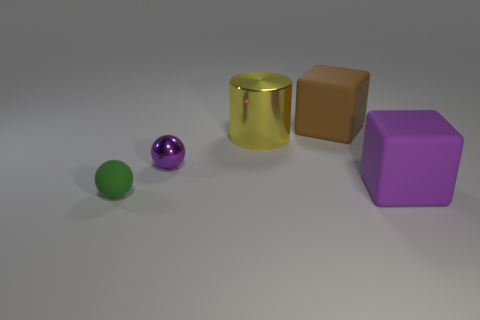Add 3 cyan rubber cylinders. How many objects exist? 8 Subtract all blocks. How many objects are left? 3 Add 5 metallic balls. How many metallic balls exist? 6 Subtract 0 brown cylinders. How many objects are left? 5 Subtract all cyan metal balls. Subtract all purple blocks. How many objects are left? 4 Add 4 purple metallic spheres. How many purple metallic spheres are left? 5 